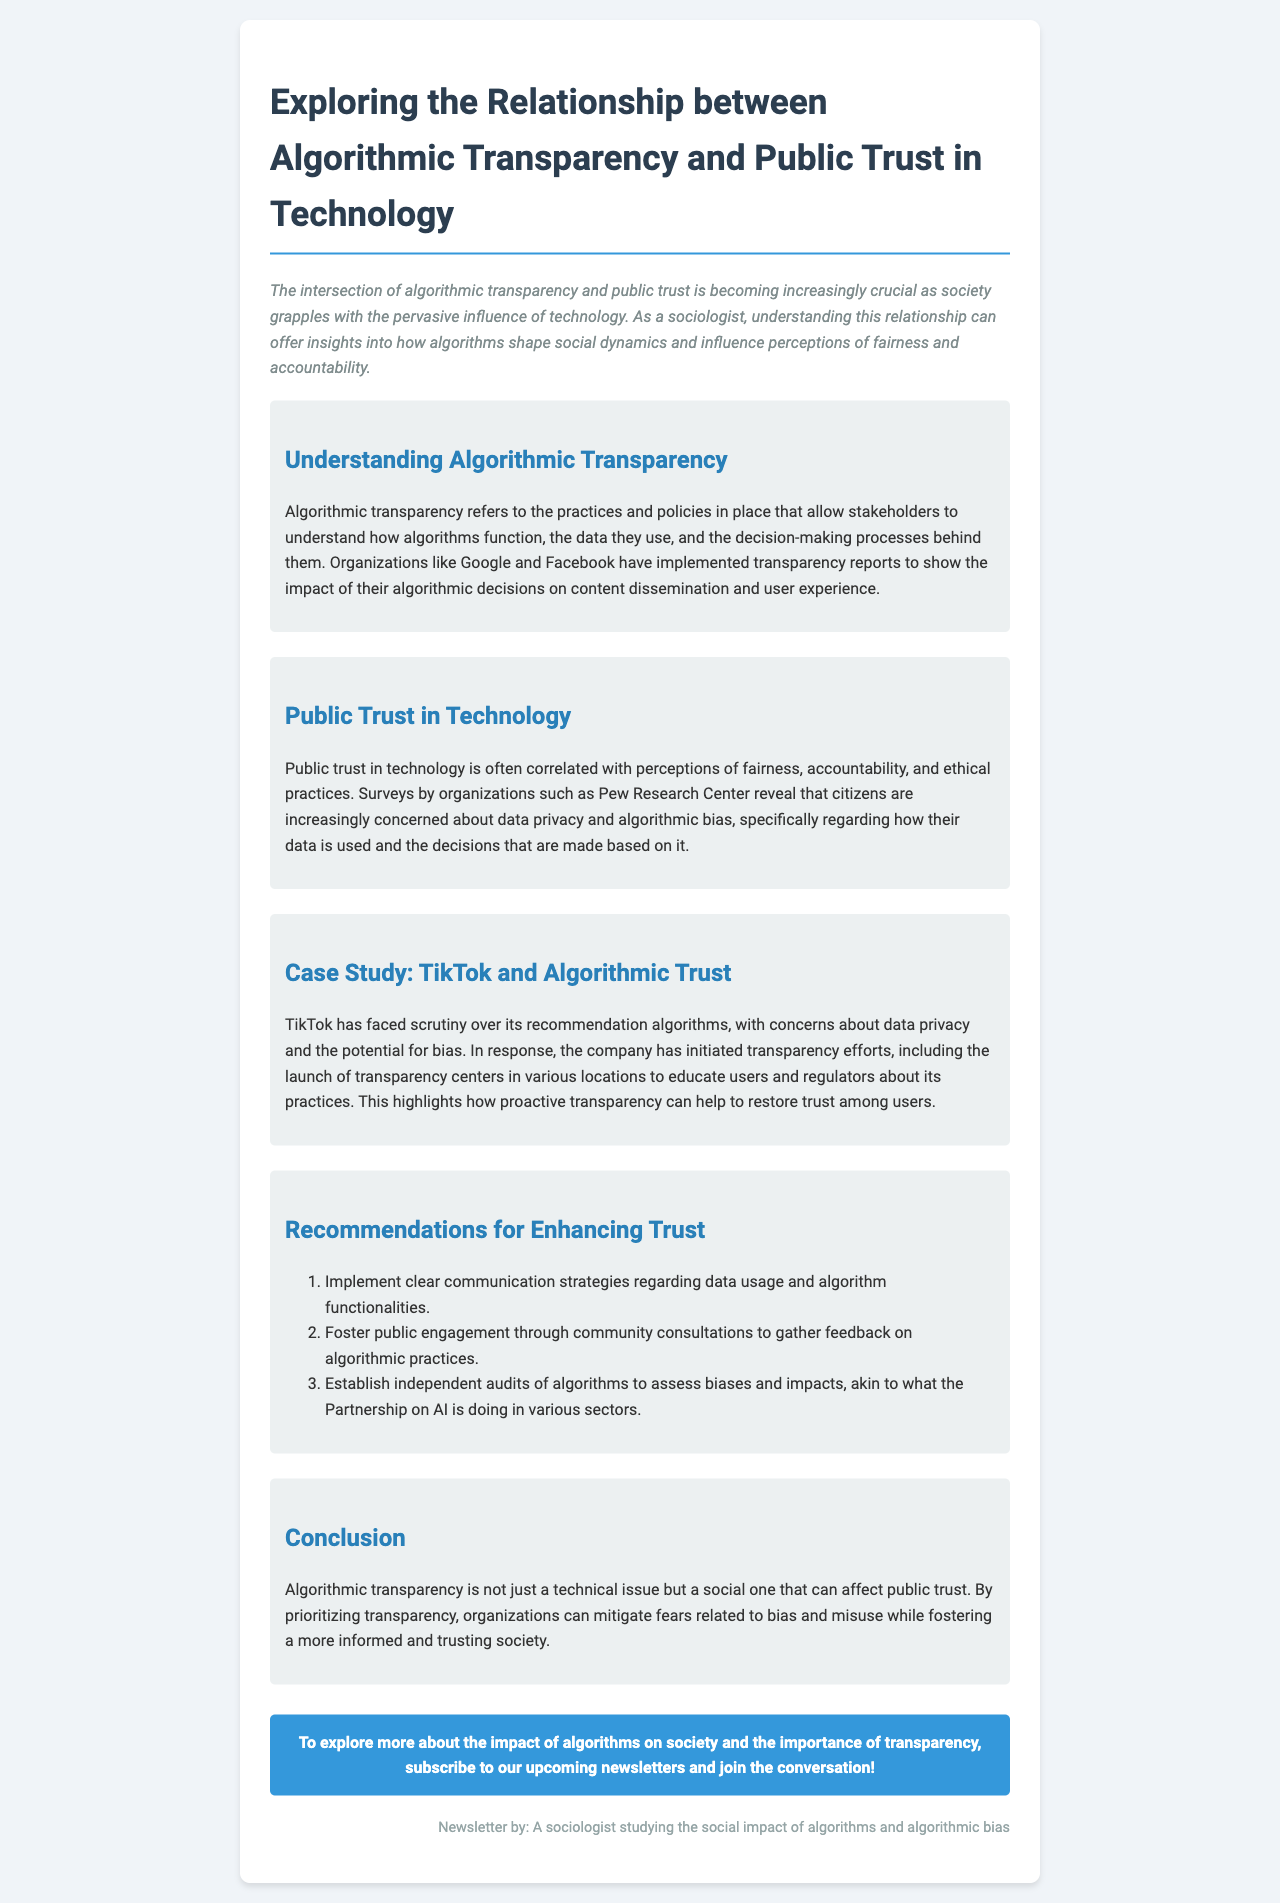what is the title of the newsletter? The title of the newsletter is stated prominently at the top of the document.
Answer: Exploring the Relationship between Algorithmic Transparency and Public Trust in Technology who launched transparency centers to educate users? The document mentions TikTok's efforts in this regard.
Answer: TikTok what is one key focus of public trust in technology? The document highlights specific concerns that contribute to public trust.
Answer: data privacy how many recommendations are provided for enhancing trust? The document lists several recommendations in an ordered list.
Answer: three what organization is mentioned for conducting independent audits of algorithms? The document refers to an organization that is actively involved in this area.
Answer: Partnership on AI what does algorithmic transparency allow stakeholders to understand? The document describes the purpose of algorithmic transparency.
Answer: how algorithms function why is algorithmic transparency considered a social issue? The conclusion emphasizes the broader implications of transparency beyond technical aspects.
Answer: affects public trust what is the color of the newsletter background? The document specifies the design features, including the background color.
Answer: #f0f4f8 